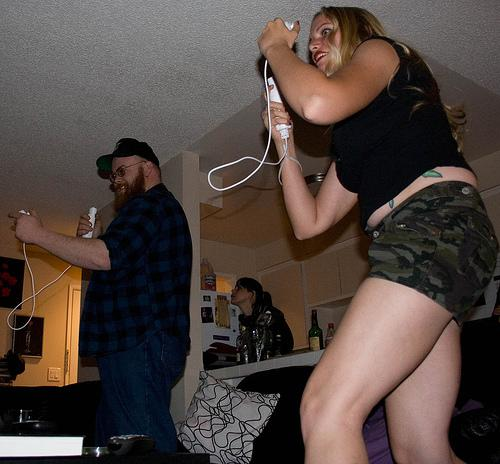Question: what are they holding?
Choices:
A. Phones.
B. Remotes.
C. Candy.
D. Cats.
Answer with the letter. Answer: B Question: what are they doing?
Choices:
A. Playing Playstation.
B. Playing XBox.
C. Playing Wii.
D. Playing a board game.
Answer with the letter. Answer: C Question: where was the picture taken?
Choices:
A. In a living room.
B. In a bathroom.
C. In a bedroom.
D. In a pantry.
Answer with the letter. Answer: A Question: when was the picture taken?
Choices:
A. During a game.
B. During a thunderstorm.
C. During a play.
D. During supper.
Answer with the letter. Answer: A Question: who is in the picture?
Choices:
A. 3 people.
B. 4 people.
C. 2 people.
D. 10 people.
Answer with the letter. Answer: A 